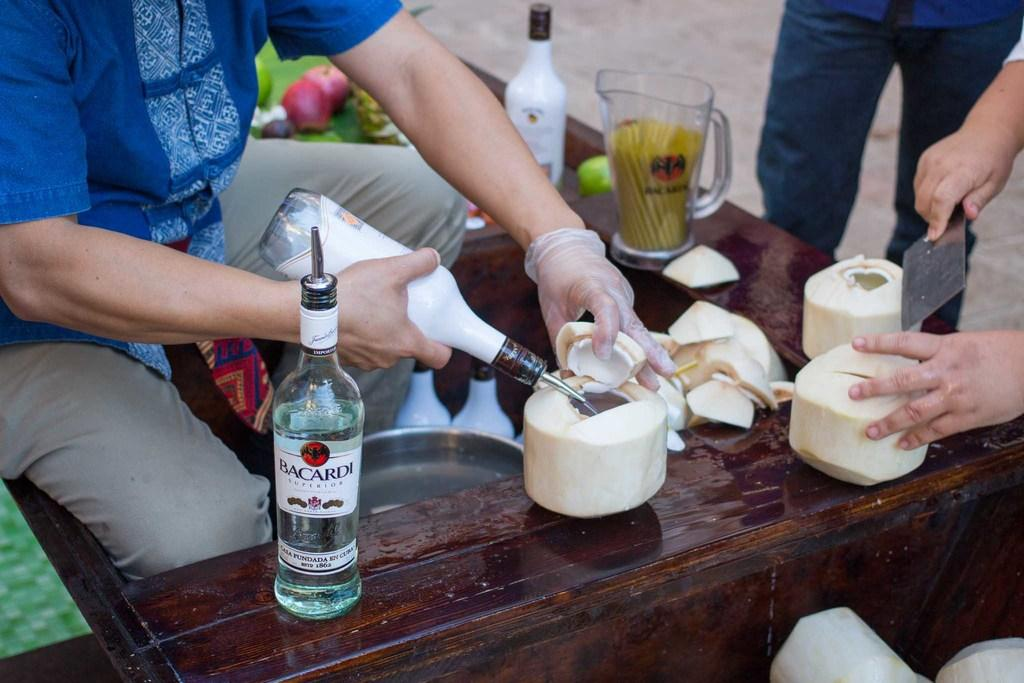<image>
Describe the image concisely. People cut open coconuts and a bottle of Bacardi sits next to them. 